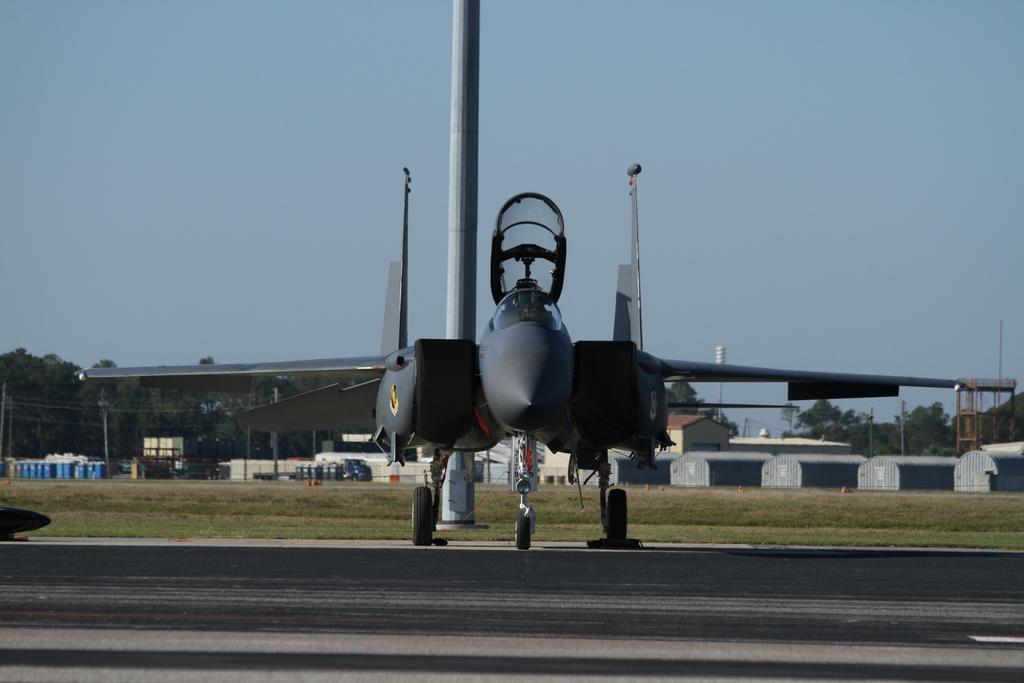Please provide a concise description of this image. In the picture we can see a road on it, we can see an aircraft and behind it, we can see a pole on the grass surface and far away from it, we can see a shed with stone pillars and under it we can see some things are placed and behind the shed we can see many trees and sky. 